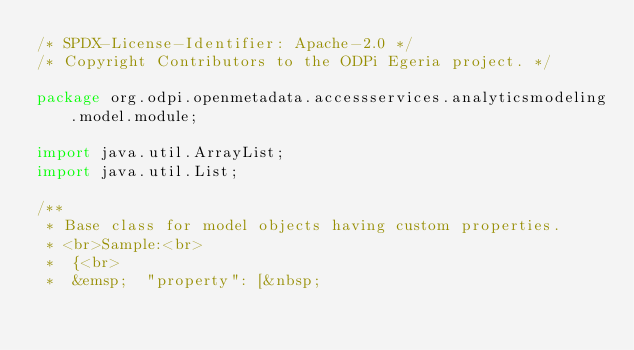<code> <loc_0><loc_0><loc_500><loc_500><_Java_>/* SPDX-License-Identifier: Apache-2.0 */
/* Copyright Contributors to the ODPi Egeria project. */

package org.odpi.openmetadata.accessservices.analyticsmodeling.model.module;

import java.util.ArrayList;
import java.util.List;

/**
 * Base class for model objects having custom properties.
 * <br>Sample:<br>
 *	{<br>
 *	&emsp;	"property": [&nbsp;</code> 